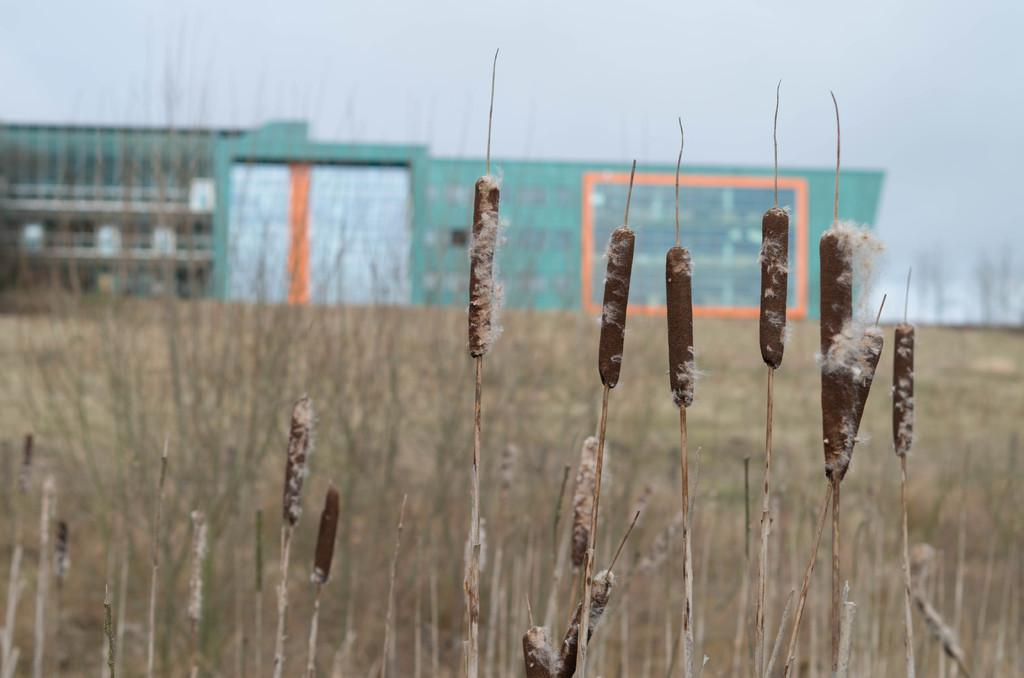What type of vegetation is present in the image? There is grass with Phragmites in the image. What can be seen in the background of the image? There is a building and the sky visible in the background of the image. How many cushions can be seen in the image? There are no cushions present in the image. What type of bean is growing in the image? There are no beans present in the image. 